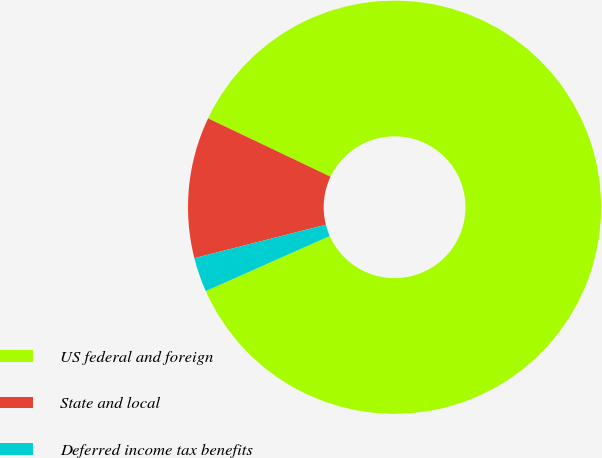Convert chart. <chart><loc_0><loc_0><loc_500><loc_500><pie_chart><fcel>US federal and foreign<fcel>State and local<fcel>Deferred income tax benefits<nl><fcel>86.27%<fcel>11.04%<fcel>2.69%<nl></chart> 